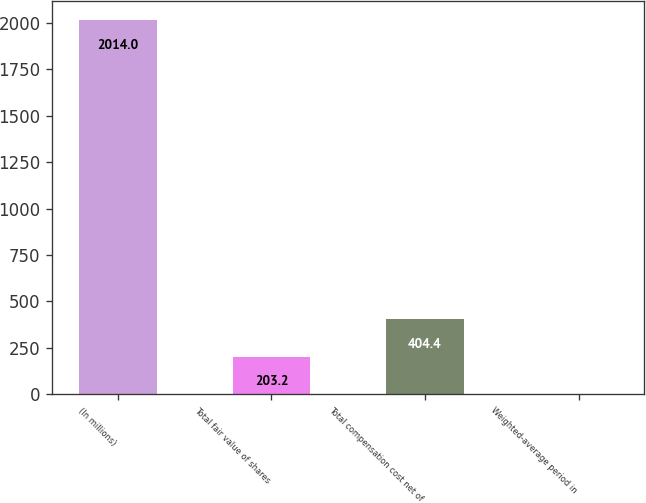Convert chart. <chart><loc_0><loc_0><loc_500><loc_500><bar_chart><fcel>(In millions)<fcel>Total fair value of shares<fcel>Total compensation cost net of<fcel>Weighted-average period in<nl><fcel>2014<fcel>203.2<fcel>404.4<fcel>2<nl></chart> 